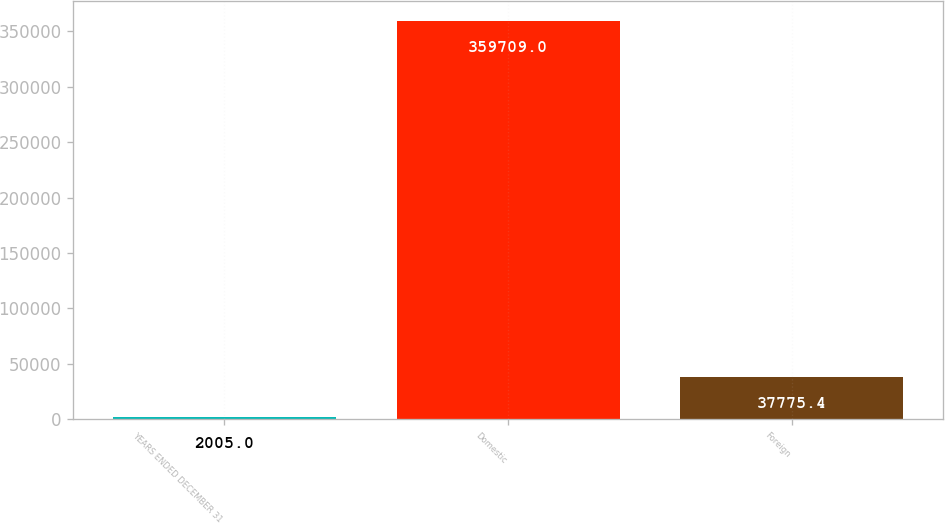<chart> <loc_0><loc_0><loc_500><loc_500><bar_chart><fcel>YEARS ENDED DECEMBER 31<fcel>Domestic<fcel>Foreign<nl><fcel>2005<fcel>359709<fcel>37775.4<nl></chart> 